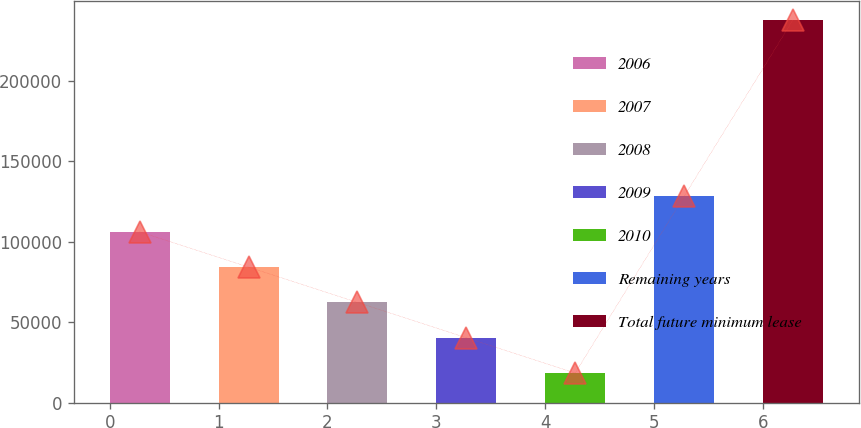Convert chart. <chart><loc_0><loc_0><loc_500><loc_500><bar_chart><fcel>2006<fcel>2007<fcel>2008<fcel>2009<fcel>2010<fcel>Remaining years<fcel>Total future minimum lease<nl><fcel>106103<fcel>84185.6<fcel>62268.4<fcel>40351.2<fcel>18434<fcel>128020<fcel>237606<nl></chart> 